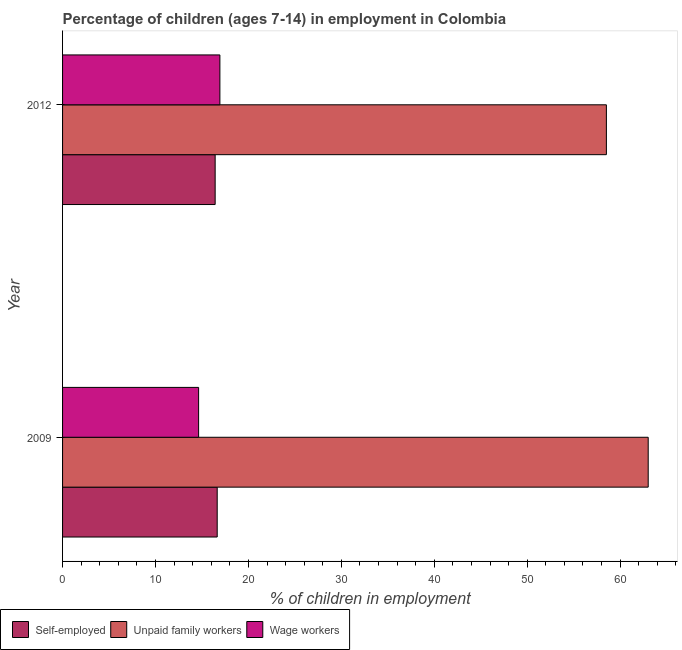Are the number of bars per tick equal to the number of legend labels?
Your answer should be very brief. Yes. How many bars are there on the 2nd tick from the top?
Provide a succinct answer. 3. How many bars are there on the 1st tick from the bottom?
Give a very brief answer. 3. What is the label of the 1st group of bars from the top?
Provide a short and direct response. 2012. In how many cases, is the number of bars for a given year not equal to the number of legend labels?
Give a very brief answer. 0. What is the percentage of children employed as unpaid family workers in 2009?
Your response must be concise. 63.02. Across all years, what is the maximum percentage of children employed as wage workers?
Give a very brief answer. 16.93. Across all years, what is the minimum percentage of children employed as wage workers?
Your answer should be compact. 14.64. In which year was the percentage of children employed as unpaid family workers maximum?
Give a very brief answer. 2009. What is the total percentage of children employed as wage workers in the graph?
Your answer should be very brief. 31.57. What is the difference between the percentage of children employed as wage workers in 2009 and that in 2012?
Make the answer very short. -2.29. What is the difference between the percentage of children employed as unpaid family workers in 2009 and the percentage of self employed children in 2012?
Make the answer very short. 46.6. What is the average percentage of self employed children per year?
Make the answer very short. 16.53. In the year 2009, what is the difference between the percentage of self employed children and percentage of children employed as wage workers?
Make the answer very short. 2. In how many years, is the percentage of children employed as unpaid family workers greater than 36 %?
Offer a very short reply. 2. What is the ratio of the percentage of children employed as wage workers in 2009 to that in 2012?
Your response must be concise. 0.86. Is the percentage of children employed as wage workers in 2009 less than that in 2012?
Your answer should be very brief. Yes. Is the difference between the percentage of self employed children in 2009 and 2012 greater than the difference between the percentage of children employed as wage workers in 2009 and 2012?
Offer a terse response. Yes. In how many years, is the percentage of self employed children greater than the average percentage of self employed children taken over all years?
Your answer should be compact. 1. What does the 3rd bar from the top in 2009 represents?
Ensure brevity in your answer.  Self-employed. What does the 3rd bar from the bottom in 2009 represents?
Offer a terse response. Wage workers. How many bars are there?
Your response must be concise. 6. Are all the bars in the graph horizontal?
Your answer should be compact. Yes. How many years are there in the graph?
Ensure brevity in your answer.  2. What is the difference between two consecutive major ticks on the X-axis?
Make the answer very short. 10. Are the values on the major ticks of X-axis written in scientific E-notation?
Your answer should be very brief. No. Does the graph contain any zero values?
Your answer should be compact. No. Where does the legend appear in the graph?
Your response must be concise. Bottom left. What is the title of the graph?
Ensure brevity in your answer.  Percentage of children (ages 7-14) in employment in Colombia. Does "Secondary education" appear as one of the legend labels in the graph?
Your answer should be compact. No. What is the label or title of the X-axis?
Provide a short and direct response. % of children in employment. What is the % of children in employment in Self-employed in 2009?
Your response must be concise. 16.64. What is the % of children in employment in Unpaid family workers in 2009?
Provide a succinct answer. 63.02. What is the % of children in employment of Wage workers in 2009?
Ensure brevity in your answer.  14.64. What is the % of children in employment of Self-employed in 2012?
Offer a very short reply. 16.42. What is the % of children in employment of Unpaid family workers in 2012?
Offer a terse response. 58.52. What is the % of children in employment of Wage workers in 2012?
Give a very brief answer. 16.93. Across all years, what is the maximum % of children in employment in Self-employed?
Give a very brief answer. 16.64. Across all years, what is the maximum % of children in employment of Unpaid family workers?
Your answer should be very brief. 63.02. Across all years, what is the maximum % of children in employment of Wage workers?
Keep it short and to the point. 16.93. Across all years, what is the minimum % of children in employment in Self-employed?
Give a very brief answer. 16.42. Across all years, what is the minimum % of children in employment in Unpaid family workers?
Provide a short and direct response. 58.52. Across all years, what is the minimum % of children in employment in Wage workers?
Keep it short and to the point. 14.64. What is the total % of children in employment of Self-employed in the graph?
Provide a succinct answer. 33.06. What is the total % of children in employment of Unpaid family workers in the graph?
Your answer should be compact. 121.54. What is the total % of children in employment in Wage workers in the graph?
Keep it short and to the point. 31.57. What is the difference between the % of children in employment of Self-employed in 2009 and that in 2012?
Provide a succinct answer. 0.22. What is the difference between the % of children in employment in Unpaid family workers in 2009 and that in 2012?
Provide a succinct answer. 4.5. What is the difference between the % of children in employment of Wage workers in 2009 and that in 2012?
Ensure brevity in your answer.  -2.29. What is the difference between the % of children in employment of Self-employed in 2009 and the % of children in employment of Unpaid family workers in 2012?
Give a very brief answer. -41.88. What is the difference between the % of children in employment of Self-employed in 2009 and the % of children in employment of Wage workers in 2012?
Your answer should be compact. -0.29. What is the difference between the % of children in employment in Unpaid family workers in 2009 and the % of children in employment in Wage workers in 2012?
Give a very brief answer. 46.09. What is the average % of children in employment of Self-employed per year?
Make the answer very short. 16.53. What is the average % of children in employment of Unpaid family workers per year?
Provide a succinct answer. 60.77. What is the average % of children in employment in Wage workers per year?
Keep it short and to the point. 15.79. In the year 2009, what is the difference between the % of children in employment of Self-employed and % of children in employment of Unpaid family workers?
Offer a terse response. -46.38. In the year 2009, what is the difference between the % of children in employment of Unpaid family workers and % of children in employment of Wage workers?
Offer a terse response. 48.38. In the year 2012, what is the difference between the % of children in employment in Self-employed and % of children in employment in Unpaid family workers?
Give a very brief answer. -42.1. In the year 2012, what is the difference between the % of children in employment of Self-employed and % of children in employment of Wage workers?
Ensure brevity in your answer.  -0.51. In the year 2012, what is the difference between the % of children in employment in Unpaid family workers and % of children in employment in Wage workers?
Offer a terse response. 41.59. What is the ratio of the % of children in employment in Self-employed in 2009 to that in 2012?
Your answer should be compact. 1.01. What is the ratio of the % of children in employment of Wage workers in 2009 to that in 2012?
Your answer should be compact. 0.86. What is the difference between the highest and the second highest % of children in employment of Self-employed?
Offer a very short reply. 0.22. What is the difference between the highest and the second highest % of children in employment of Unpaid family workers?
Your answer should be very brief. 4.5. What is the difference between the highest and the second highest % of children in employment in Wage workers?
Keep it short and to the point. 2.29. What is the difference between the highest and the lowest % of children in employment in Self-employed?
Provide a succinct answer. 0.22. What is the difference between the highest and the lowest % of children in employment in Wage workers?
Your answer should be compact. 2.29. 